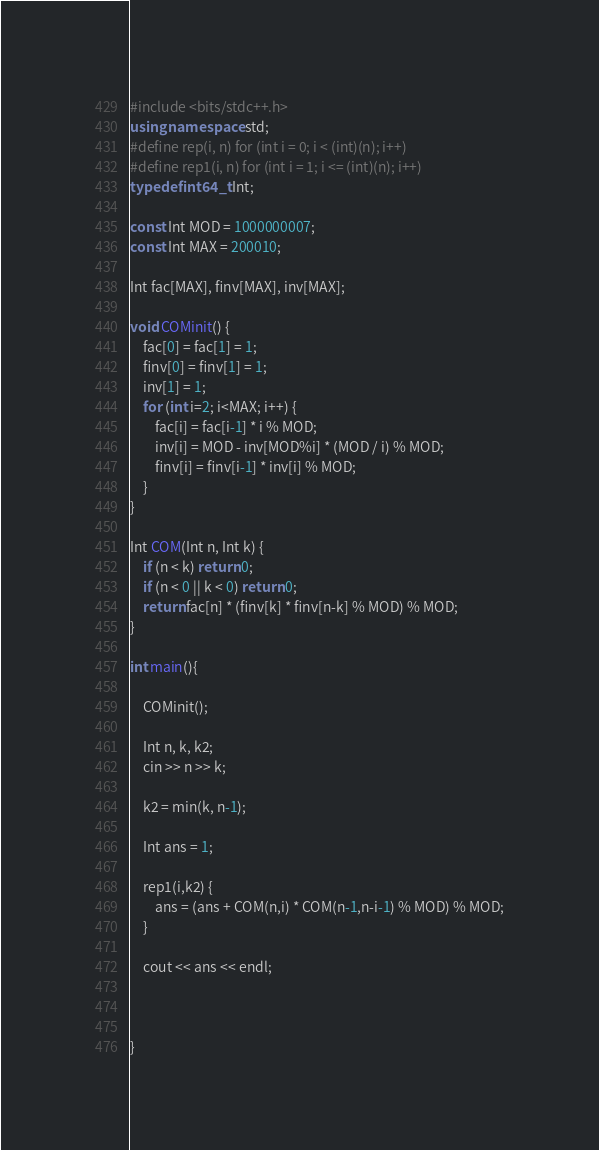Convert code to text. <code><loc_0><loc_0><loc_500><loc_500><_C++_>#include <bits/stdc++.h>
using namespace std;
#define rep(i, n) for (int i = 0; i < (int)(n); i++)
#define rep1(i, n) for (int i = 1; i <= (int)(n); i++)
typedef int64_t Int;

const Int MOD = 1000000007;
const Int MAX = 200010;

Int fac[MAX], finv[MAX], inv[MAX];

void COMinit() {
    fac[0] = fac[1] = 1;
    finv[0] = finv[1] = 1;
    inv[1] = 1;
    for (int i=2; i<MAX; i++) {
        fac[i] = fac[i-1] * i % MOD;
        inv[i] = MOD - inv[MOD%i] * (MOD / i) % MOD;
        finv[i] = finv[i-1] * inv[i] % MOD;
    }
}

Int COM(Int n, Int k) {
    if (n < k) return 0;
    if (n < 0 || k < 0) return 0;
    return fac[n] * (finv[k] * finv[n-k] % MOD) % MOD;
}

int main(){ 

    COMinit();

    Int n, k, k2;
    cin >> n >> k;

    k2 = min(k, n-1);

    Int ans = 1;

    rep1(i,k2) {
        ans = (ans + COM(n,i) * COM(n-1,n-i-1) % MOD) % MOD;
    }

    cout << ans << endl;


    
}
</code> 